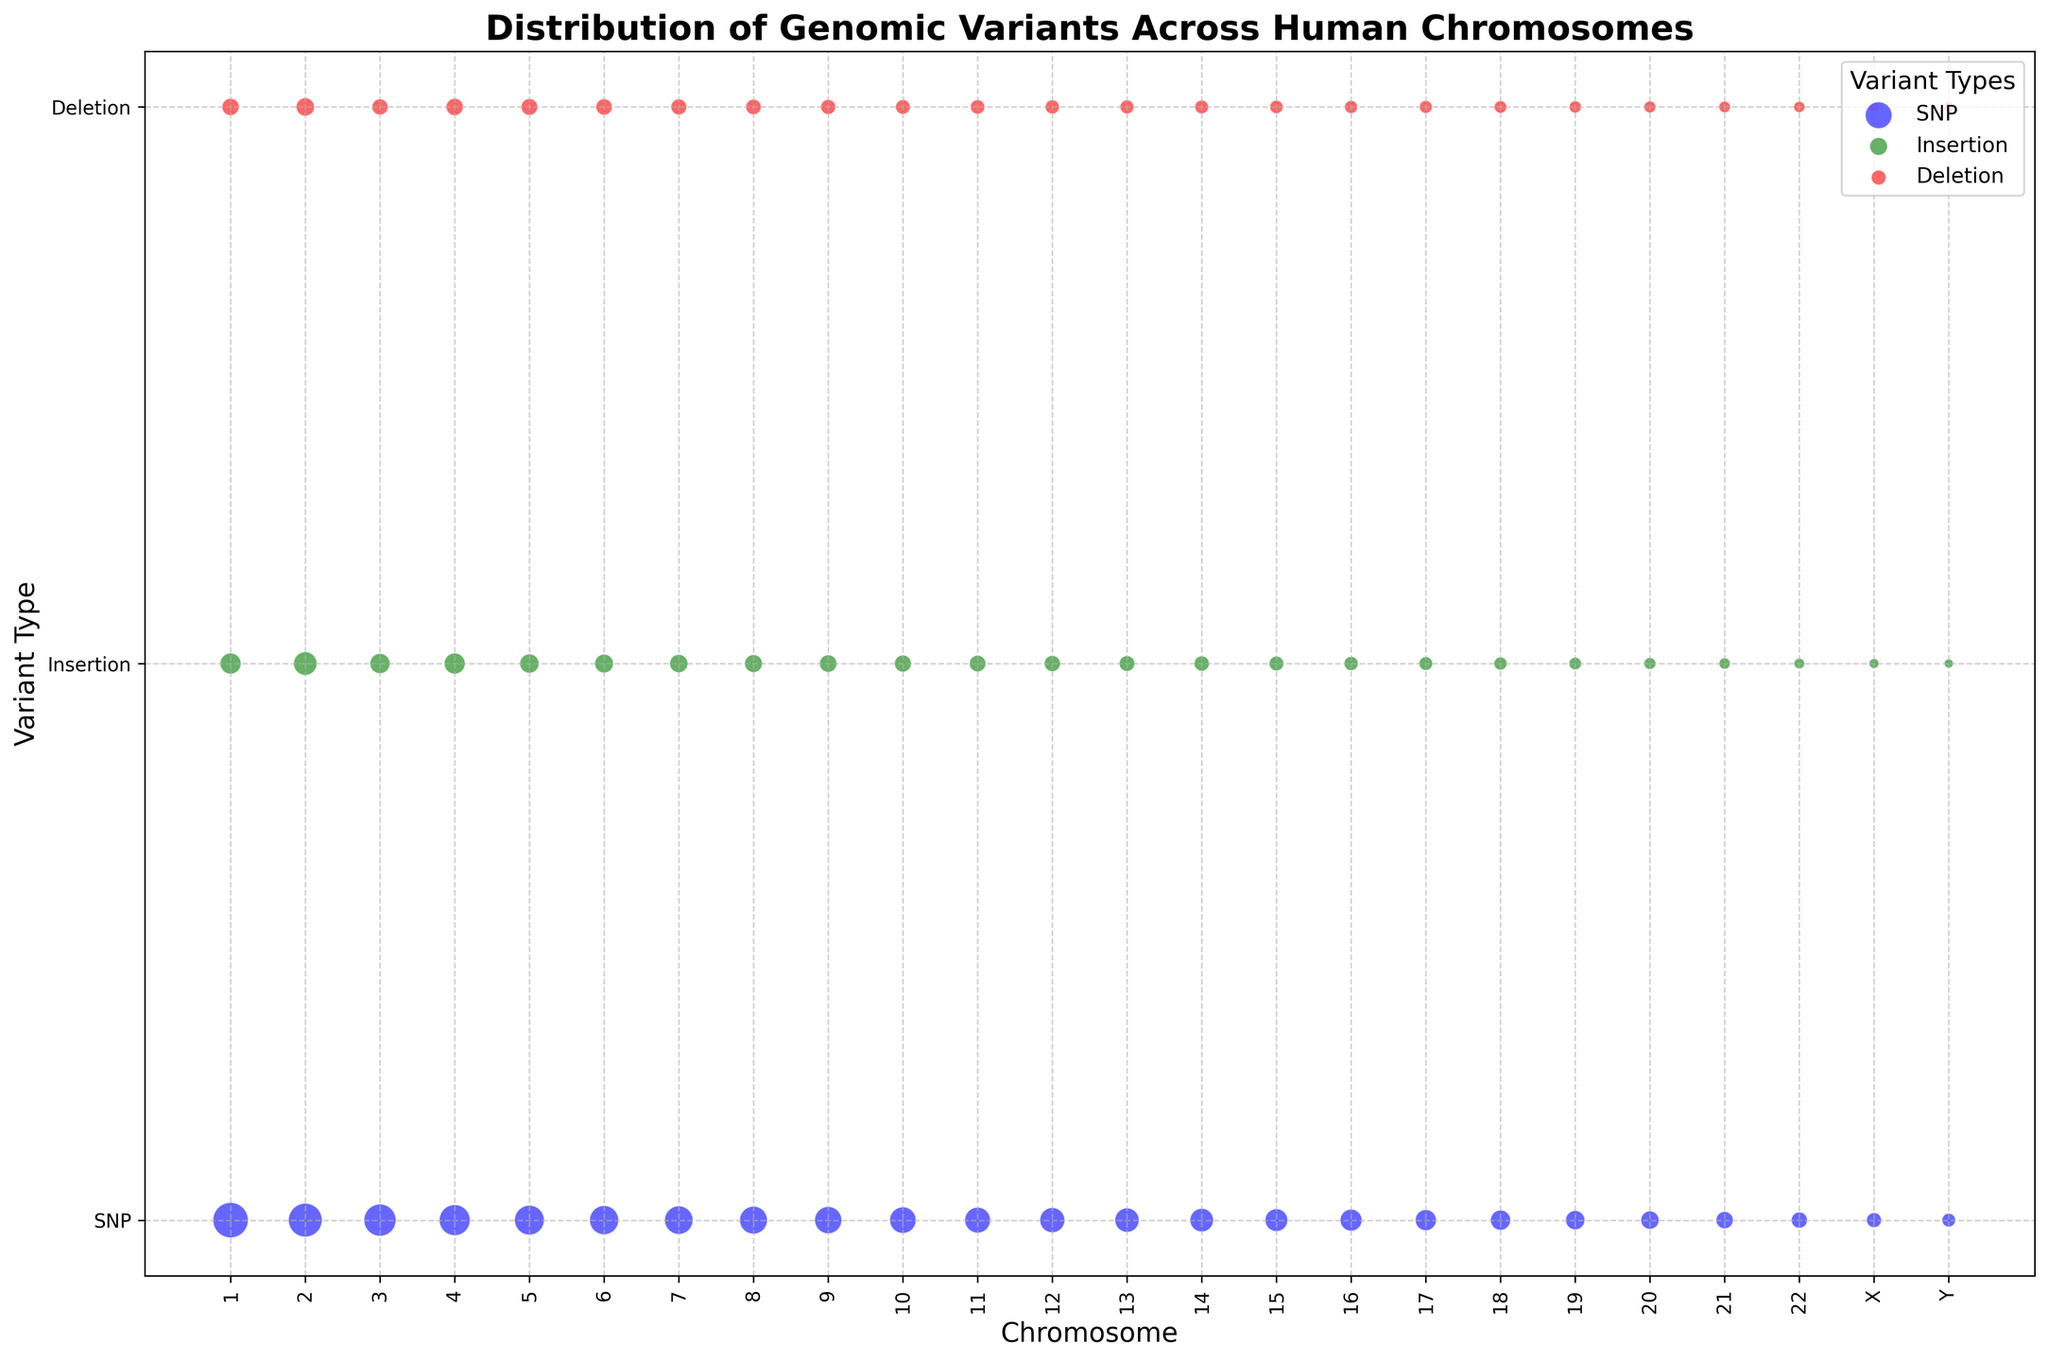Which chromosome has the highest count of SNPs? By looking at the size of the blue bubbles on the x-axis which represents chromosomes and variant types on the y-axis, we can visually verify which chromosome has the largest bubble. The largest blue bubble is associated with Chromosome 1.
Answer: Chromosome 1 What is the total count of Insertions on Chromosomes 2 and 3? To get the total count of Insertions on Chromosomes 2 and 3, find the green bubbles on the scatter plot corresponding to these chromosomes and sum their counts: 15000 (Chromosome 2) + 11000 (Chromosome 3) = 26000.
Answer: 26000 Compare the counts of Deletions on Chromosomes 7 and 9. Which chromosome has a higher count? Locate the red bubbles for Chromosomes 7 and 9. Chromosome 7 has a count of 6800 and Chromosome 9 has a count of 6000. Since 6800 > 6000, Chromosome 7 has a higher count of Deletions.
Answer: Chromosome 7 Are there more Insertions or Deletions on Chromosome 10? Look at the green and red bubbles on Chromosome 10. The count for Insertions is 7800 and the count for Deletions is 5800. Since 7800 > 5800, there are more Insertions than Deletions on Chromosome 10.
Answer: Insertions What is the count of SNPs on Chromosome 22? Locate the blue bubble for Chromosome 22 and check the numerical value displayed inside or beside it. The count of SNPs on Chromosome 22 is 7000.
Answer: 7000 How does the size of the bubble for SNPs on Chromosome 1 compare to the size of the bubble for SNPs on Chromosome 21? Evaluate the difference in size between the blue bubbles on Chromosome 1 and Chromosome 21. Since SNPs on Chromosome 1 have a count of 34000 and Chromosome 21 has a count of 8000, the bubble on Chromosome 1 is significantly larger.
Answer: Chromosome 1 is significantly larger Which variant type generally has the largest bubbles across all chromosomes? By observing the plot, the largest bubbles appear to be consistently associated with the blue color, representing SNPs. This suggests that SNPs generally have the largest counts across all chromosomes.
Answer: SNPs 